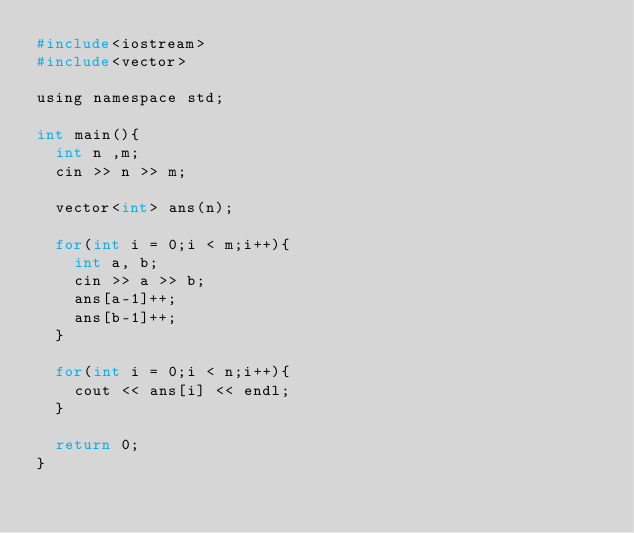Convert code to text. <code><loc_0><loc_0><loc_500><loc_500><_C_>#include<iostream>
#include<vector>

using namespace std;

int main(){
	int n ,m;
	cin >> n >> m;
	
	vector<int> ans(n);
	
	for(int i = 0;i < m;i++){
		int a, b;
		cin >> a >> b;
		ans[a-1]++; 
		ans[b-1]++;
	}
	
	for(int i = 0;i < n;i++){
		cout << ans[i] << endl;
	}
	
	return 0;
}</code> 